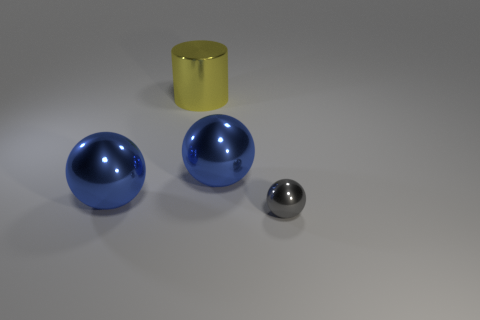Is there a big cylinder that has the same material as the small gray object?
Make the answer very short. Yes. What is the color of the cylinder?
Your answer should be very brief. Yellow. Does the large object right of the big yellow shiny cylinder have the same shape as the tiny object?
Your answer should be very brief. Yes. What shape is the large metal thing that is to the left of the large metal thing that is behind the large blue thing that is to the right of the cylinder?
Offer a terse response. Sphere. There is a blue thing on the left side of the metal cylinder; what is it made of?
Keep it short and to the point. Metal. How many other objects are the same shape as the yellow object?
Your answer should be very brief. 0. Do the yellow thing and the gray object have the same size?
Ensure brevity in your answer.  No. Is the number of blue metal balls that are to the left of the metal cylinder greater than the number of tiny shiny balls in front of the gray object?
Make the answer very short. Yes. How many other things are there of the same size as the gray ball?
Provide a succinct answer. 0. Are there more things behind the gray object than small metal cylinders?
Offer a terse response. Yes. 